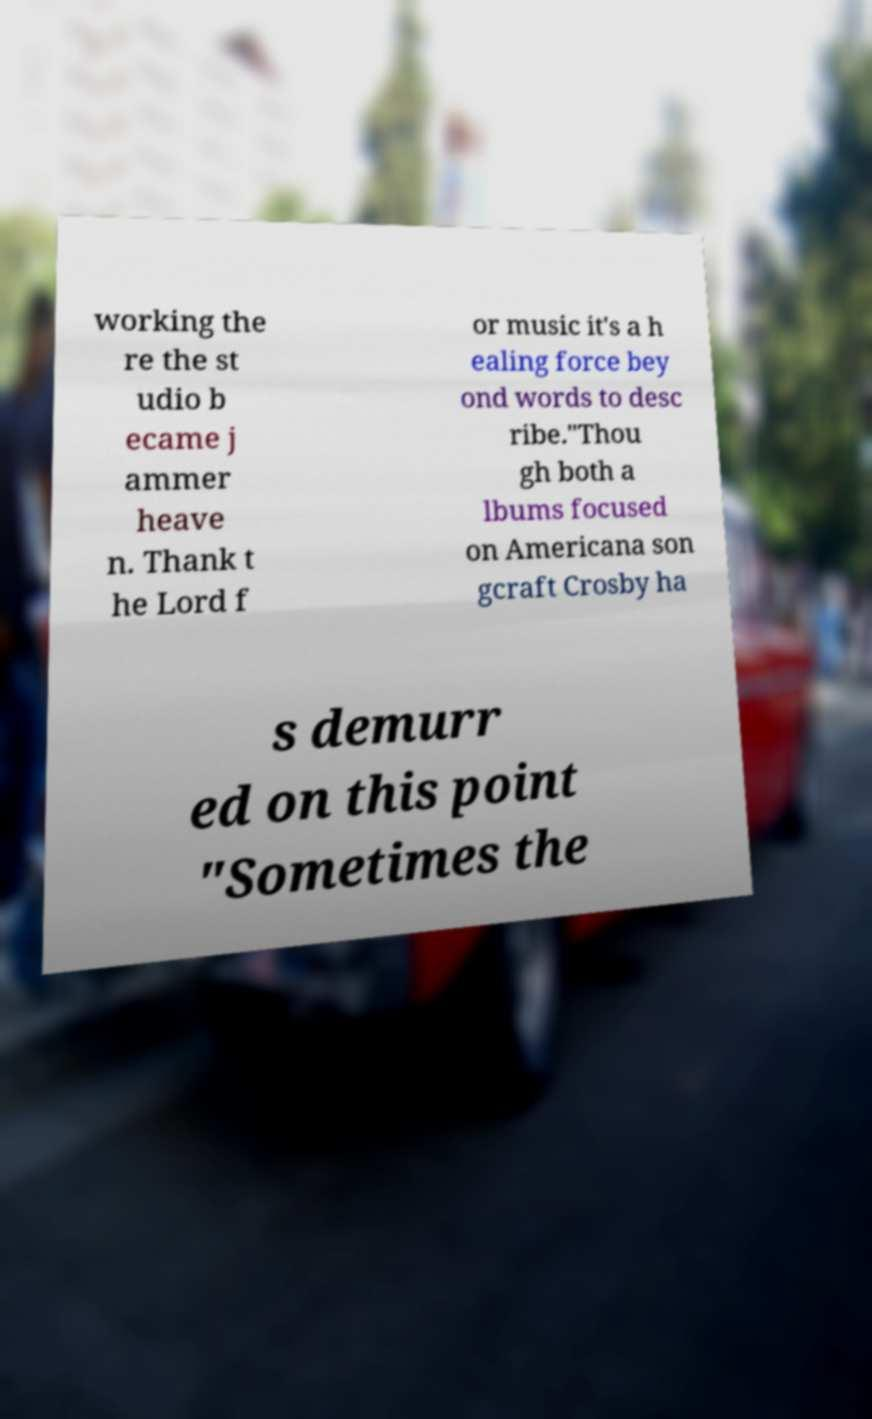Please identify and transcribe the text found in this image. working the re the st udio b ecame j ammer heave n. Thank t he Lord f or music it's a h ealing force bey ond words to desc ribe."Thou gh both a lbums focused on Americana son gcraft Crosby ha s demurr ed on this point "Sometimes the 